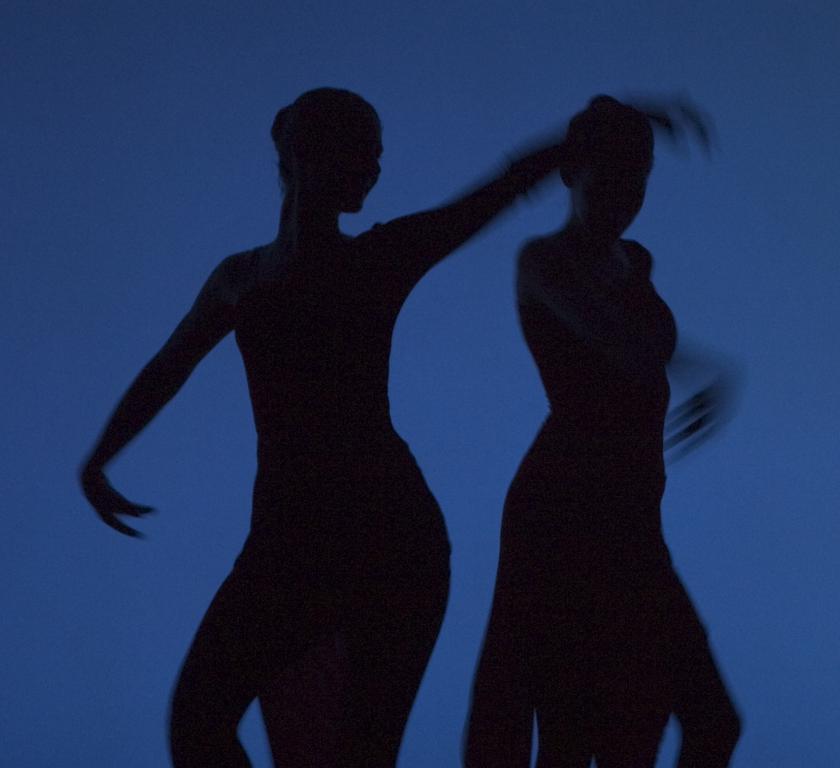Describe this image in one or two sentences. In this image there are persons dancing. 